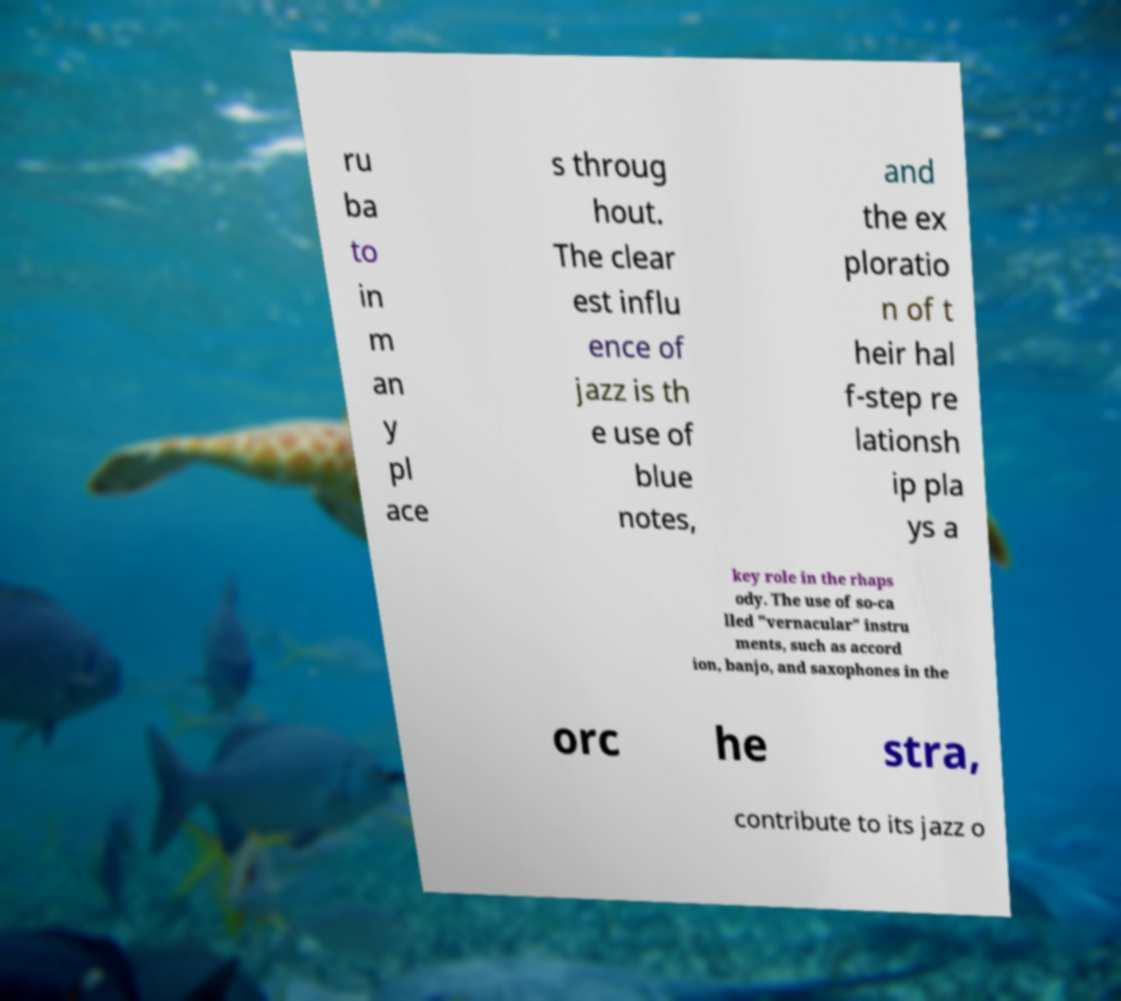For documentation purposes, I need the text within this image transcribed. Could you provide that? ru ba to in m an y pl ace s throug hout. The clear est influ ence of jazz is th e use of blue notes, and the ex ploratio n of t heir hal f-step re lationsh ip pla ys a key role in the rhaps ody. The use of so-ca lled "vernacular" instru ments, such as accord ion, banjo, and saxophones in the orc he stra, contribute to its jazz o 